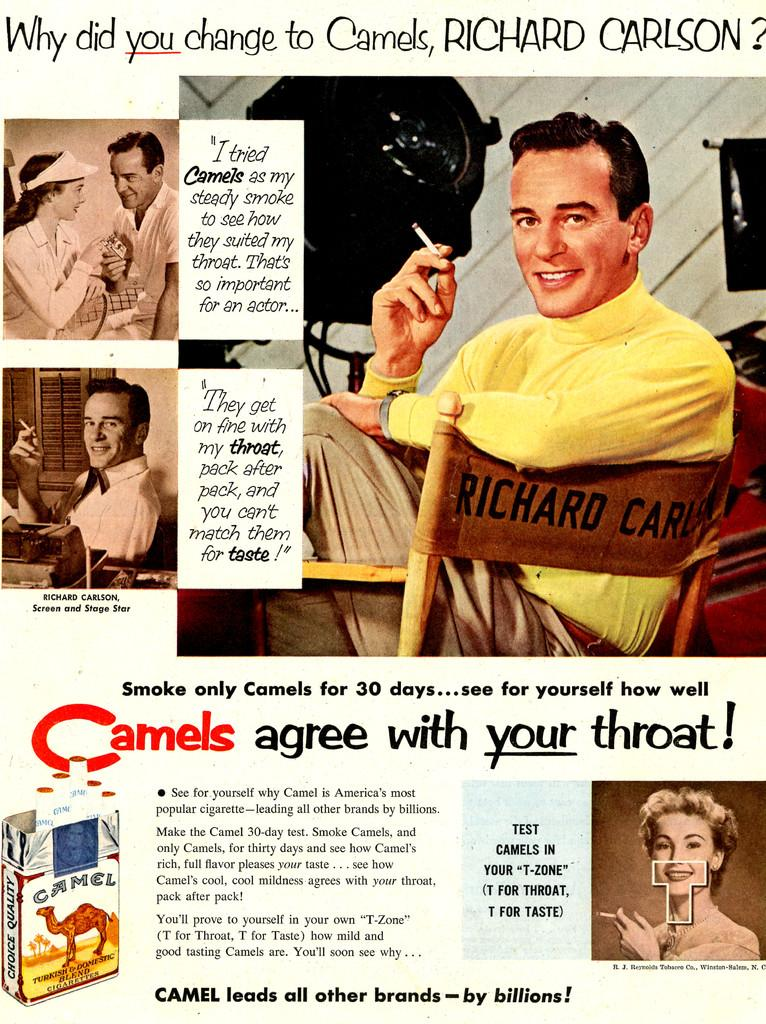<image>
Give a short and clear explanation of the subsequent image. A retro advertisement featuring Richard carlson for Camel brand cigarettes. 